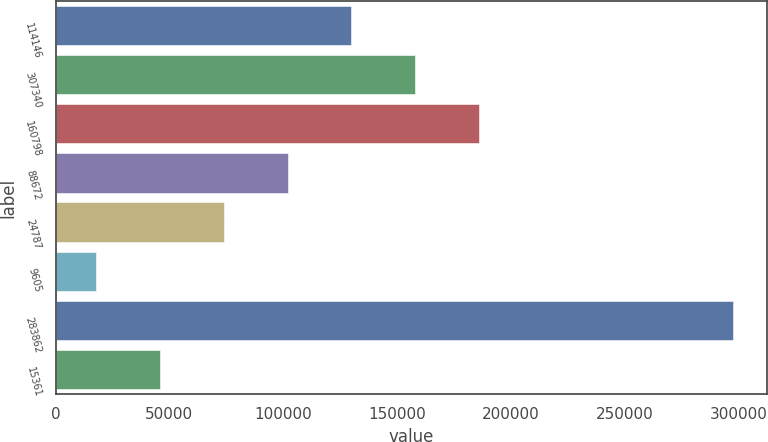Convert chart to OTSL. <chart><loc_0><loc_0><loc_500><loc_500><bar_chart><fcel>114146<fcel>307340<fcel>160798<fcel>88672<fcel>24787<fcel>9605<fcel>283862<fcel>15361<nl><fcel>129828<fcel>157792<fcel>185756<fcel>101864<fcel>73900.6<fcel>17973<fcel>297611<fcel>45936.8<nl></chart> 